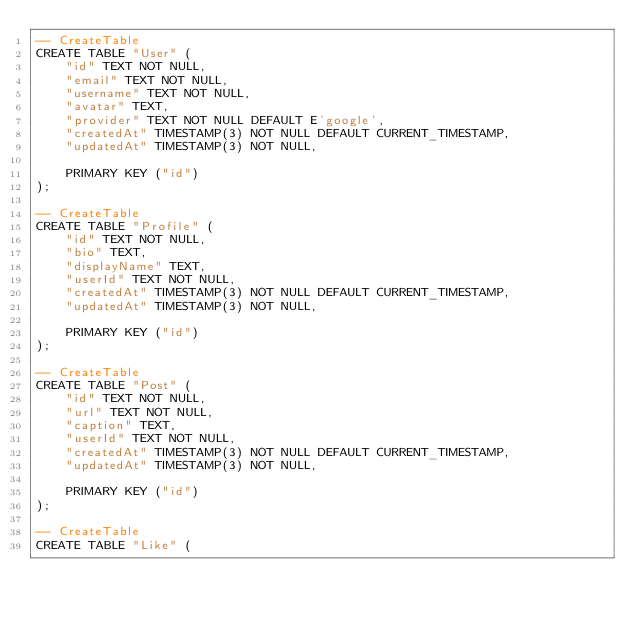Convert code to text. <code><loc_0><loc_0><loc_500><loc_500><_SQL_>-- CreateTable
CREATE TABLE "User" (
    "id" TEXT NOT NULL,
    "email" TEXT NOT NULL,
    "username" TEXT NOT NULL,
    "avatar" TEXT,
    "provider" TEXT NOT NULL DEFAULT E'google',
    "createdAt" TIMESTAMP(3) NOT NULL DEFAULT CURRENT_TIMESTAMP,
    "updatedAt" TIMESTAMP(3) NOT NULL,

    PRIMARY KEY ("id")
);

-- CreateTable
CREATE TABLE "Profile" (
    "id" TEXT NOT NULL,
    "bio" TEXT,
    "displayName" TEXT,
    "userId" TEXT NOT NULL,
    "createdAt" TIMESTAMP(3) NOT NULL DEFAULT CURRENT_TIMESTAMP,
    "updatedAt" TIMESTAMP(3) NOT NULL,

    PRIMARY KEY ("id")
);

-- CreateTable
CREATE TABLE "Post" (
    "id" TEXT NOT NULL,
    "url" TEXT NOT NULL,
    "caption" TEXT,
    "userId" TEXT NOT NULL,
    "createdAt" TIMESTAMP(3) NOT NULL DEFAULT CURRENT_TIMESTAMP,
    "updatedAt" TIMESTAMP(3) NOT NULL,

    PRIMARY KEY ("id")
);

-- CreateTable
CREATE TABLE "Like" (</code> 